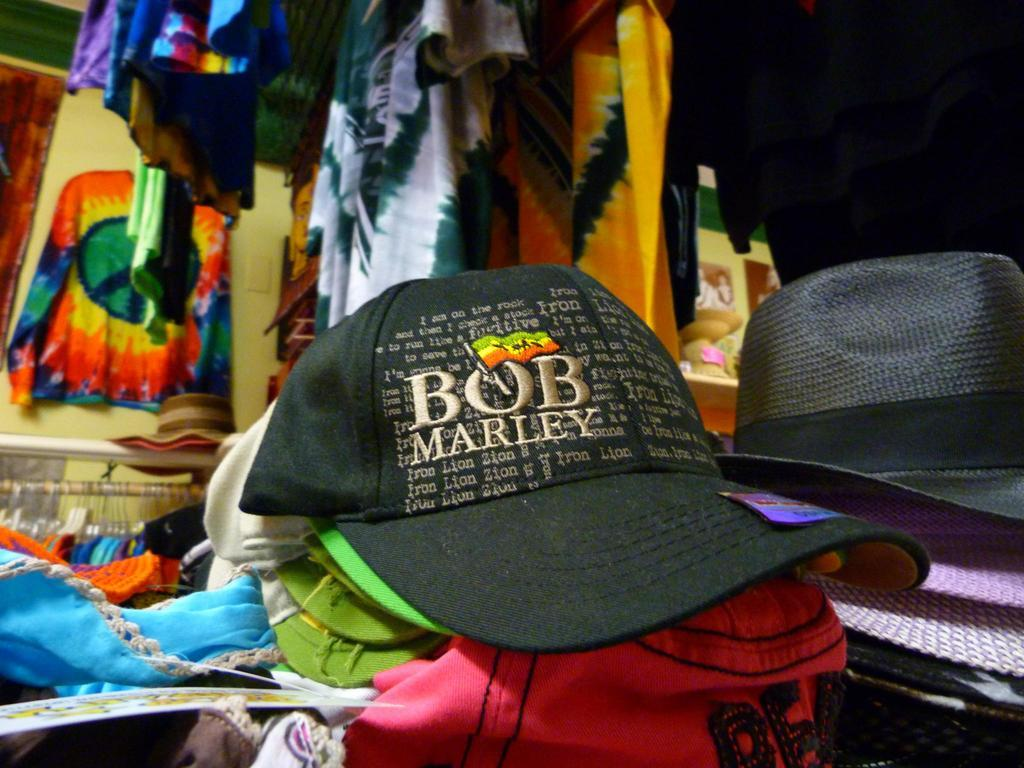What type of accessories are in the image? There are caps in the image. Can you describe the caps in the image? The caps are in different colors. What else can be seen in the image besides the caps? There are clothes in the image. How are the clothes different from each other in the image? The clothes are in different colors. How many crates are visible in the image? There are no crates present in the image. What type of nerve is being stimulated by the caps in the image? The image does not show any nerve stimulation; it only features caps and clothes. 